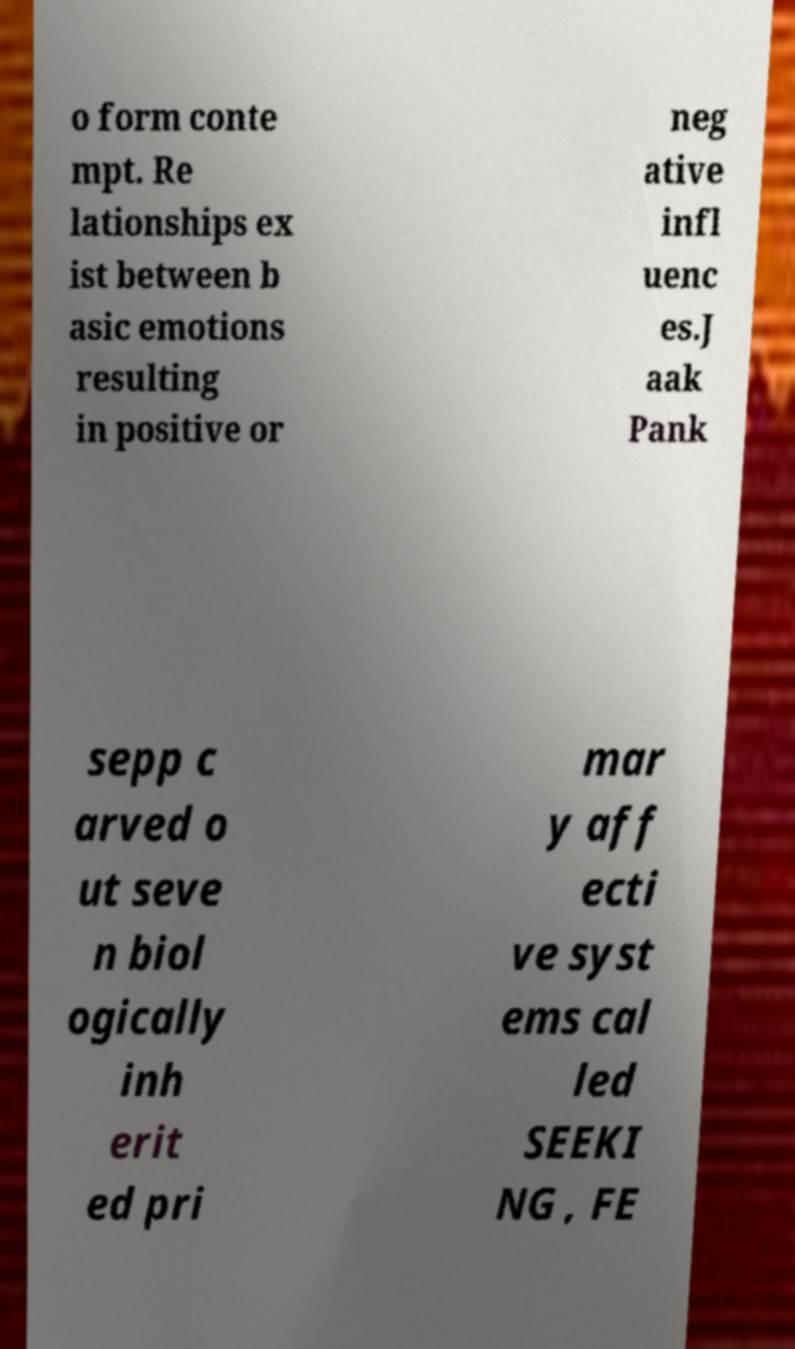For documentation purposes, I need the text within this image transcribed. Could you provide that? o form conte mpt. Re lationships ex ist between b asic emotions resulting in positive or neg ative infl uenc es.J aak Pank sepp c arved o ut seve n biol ogically inh erit ed pri mar y aff ecti ve syst ems cal led SEEKI NG , FE 